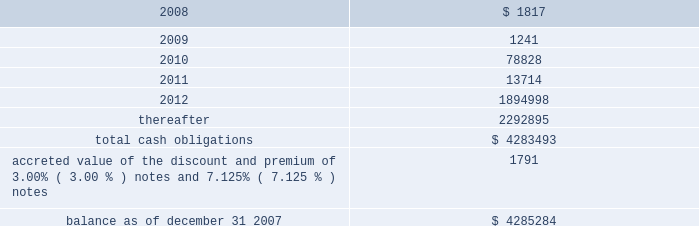American tower corporation and subsidiaries notes to consolidated financial statements 2014 ( continued ) maturities 2014as of december 31 , 2007 , aggregate carrying value of long-term debt , including capital leases , for the next five years and thereafter are estimated to be ( in thousands ) : year ending december 31 .
Acquisitions during the years ended december 31 , 2007 , 2006 and 2005 , the company used cash to acquire a total of ( i ) 293 towers and the assets of a structural analysis firm for approximately $ 44.0 million in cash ( ii ) 84 towers and 6 in-building distributed antenna systems for approximately $ 14.3 million and ( iii ) 30 towers for approximately $ 6.0 million in cash , respectively .
The tower asset acquisitions were primarily in mexico and brazil under ongoing agreements .
During the year ended december 31 , 2005 , the company also completed its merger with spectrasite , inc .
Pursuant to which the company acquired approximately 7800 towers and 100 in-building distributed antenna systems .
Under the terms of the merger agreement , in august 2005 , spectrasite , inc .
Merged with a wholly- owned subsidiary of the company , and each share of spectrasite , inc .
Common stock converted into the right to receive 3.575 shares of the company 2019s class a common stock .
The company issued approximately 169.5 million shares of its class a common stock and reserved for issuance approximately 9.9 million and 6.8 million of class a common stock pursuant to spectrasite , inc .
Options and warrants , respectively , assumed in the merger .
The final allocation of the $ 3.1 billion purchase price is summarized in the company 2019s annual report on form 10-k for the year ended december 31 , 2006 .
The acquisitions consummated by the company during 2007 , 2006 and 2005 , have been accounted for under the purchase method of accounting in accordance with sfas no .
141 201cbusiness combinations 201d ( sfas no .
141 ) .
The purchase prices have been allocated to the net assets acquired and the liabilities assumed based on their estimated fair values at the date of acquisition .
The company primarily acquired its tower assets from third parties in one of two types of transactions : the purchase of a business or the purchase of assets .
The structure of each transaction affects the way the company allocates purchase price within the consolidated financial statements .
In the case of tower assets acquired through the purchase of a business , such as the company 2019s merger with spectrasite , inc. , the company allocates the purchase price to the assets acquired and liabilities assumed at their estimated fair values as of the date of acquisition .
The excess of the purchase price paid by the company over the estimated fair value of net assets acquired has been recorded as goodwill .
In the case of an asset purchase , the company first allocates the purchase price to property and equipment for the appraised value of the towers and to identifiable intangible assets ( primarily acquired customer base ) .
The company then records any remaining purchase price within intangible assets as a 201cnetwork location intangible . 201d .
Assuming full exercise of the options and warrants assumed , what is the total millions of shares of class a common stock in the spectrasite deal? 
Computations: ((169.5 + 9.9) + 6.8)
Answer: 186.2. 